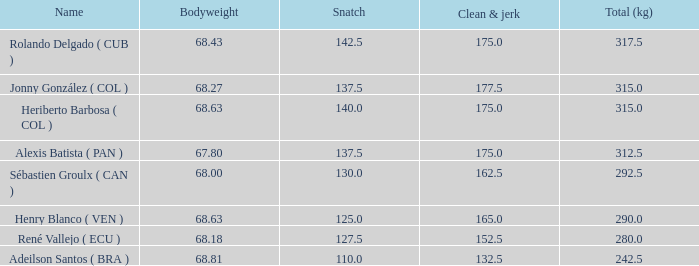Name the average clean and jerk for snatch of 140 and total kg less than 315 None. 